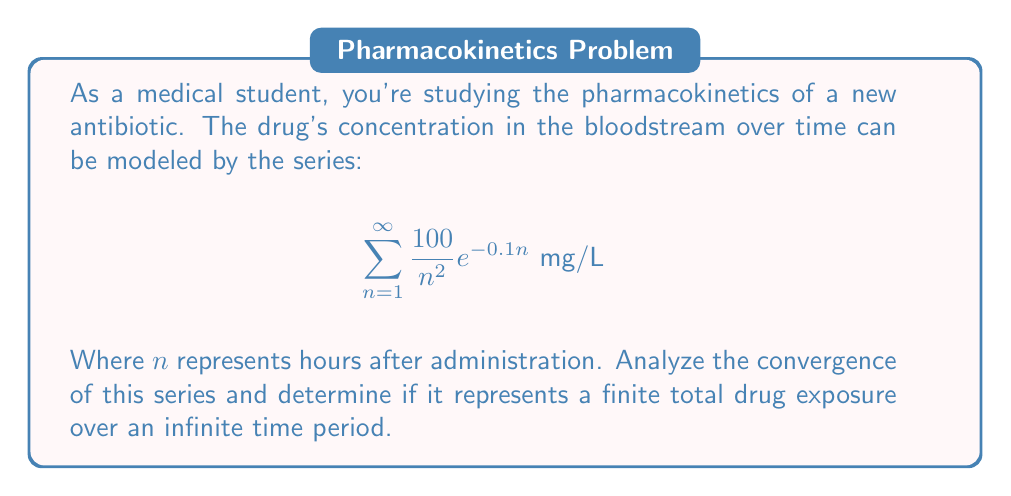Could you help me with this problem? To analyze the convergence of this series, we'll use the ratio test:

1) Let $a_n = \frac{100}{n^2} e^{-0.1n}$

2) Form the ratio of successive terms:
   $$\lim_{n \to \infty} \left|\frac{a_{n+1}}{a_n}\right| = \lim_{n \to \infty} \left|\frac{\frac{100}{(n+1)^2} e^{-0.1(n+1)}}{\frac{100}{n^2} e^{-0.1n}}\right|$$

3) Simplify:
   $$\lim_{n \to \infty} \left|\frac{n^2}{(n+1)^2} e^{-0.1}\right|$$

4) As $n \to \infty$, $\frac{n^2}{(n+1)^2} \to 1$, so:
   $$\lim_{n \to \infty} \left|\frac{a_{n+1}}{a_n}\right| = e^{-0.1} \approx 0.9048$$

5) Since this limit is less than 1, the series converges by the ratio test.

6) The convergence of the series implies that the total drug exposure over an infinite time period is finite.

This result is consistent with the pharmacokinetic principle of drug elimination, where the concentration asymptotically approaches zero over time.
Answer: The series converges; finite total drug exposure. 